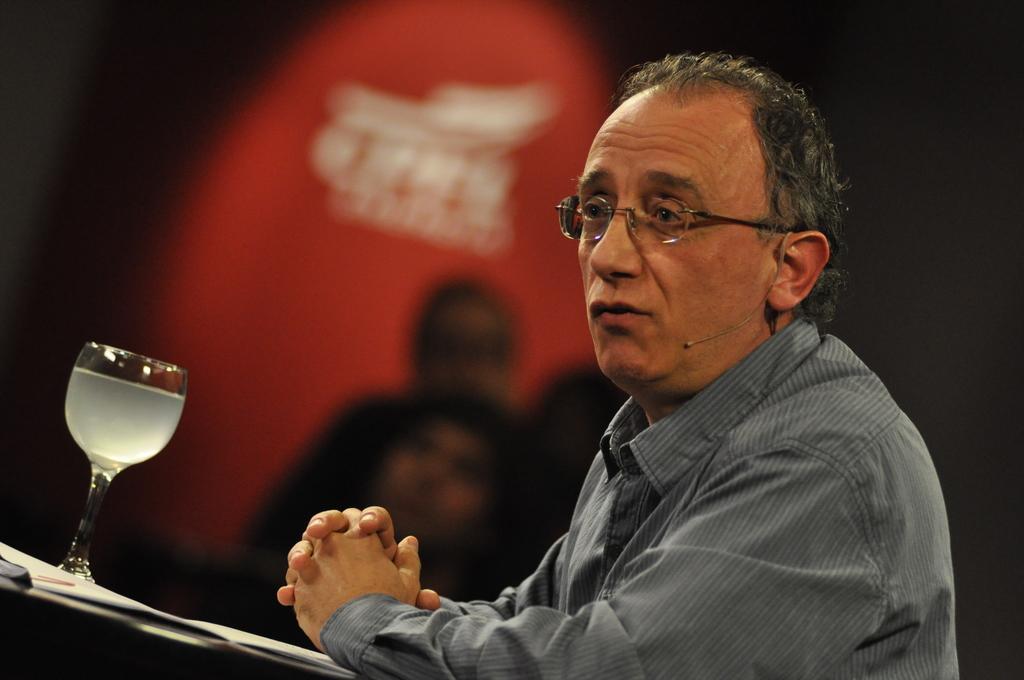Could you give a brief overview of what you see in this image? This image has a person wearing specs and a shirt is before a table having glass on it. There are few people at the backside of this person. 